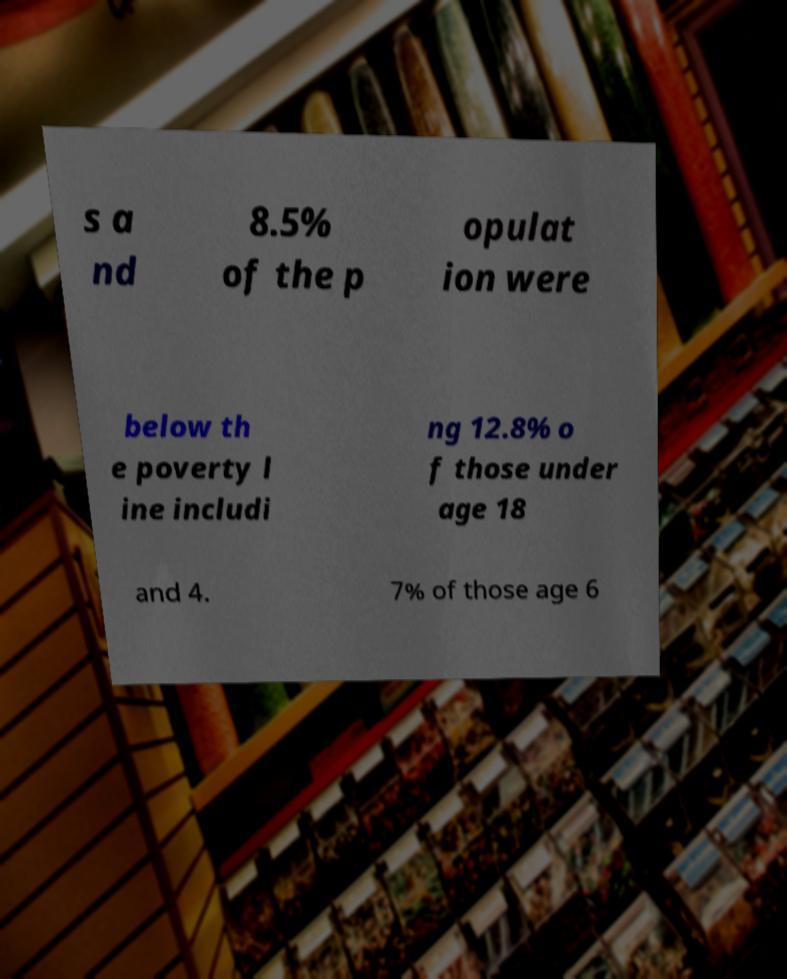Please read and relay the text visible in this image. What does it say? s a nd 8.5% of the p opulat ion were below th e poverty l ine includi ng 12.8% o f those under age 18 and 4. 7% of those age 6 